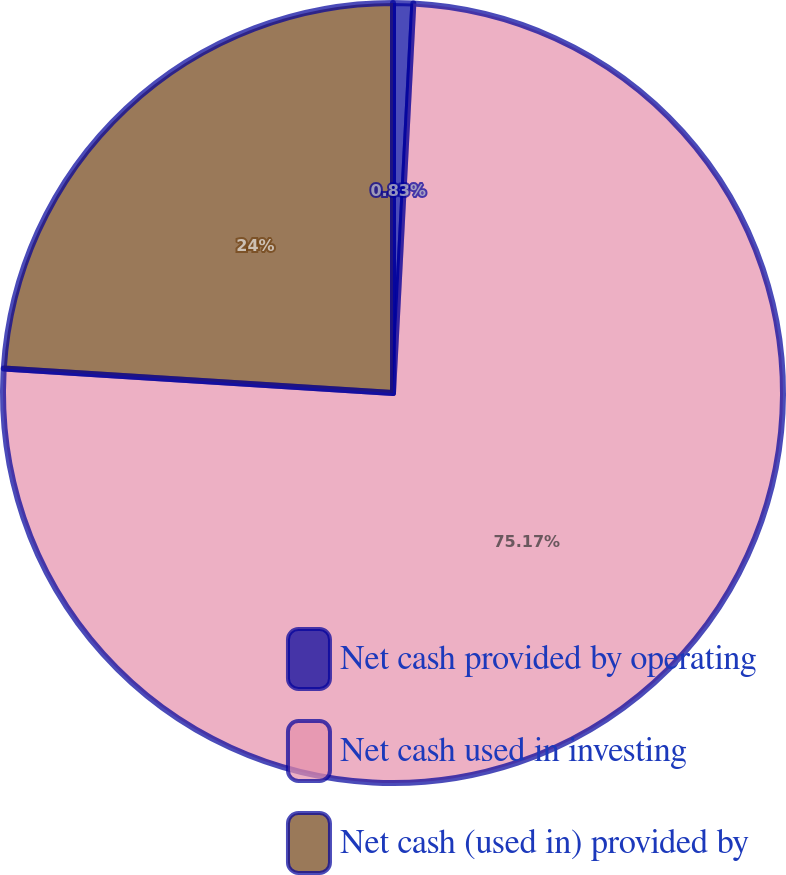<chart> <loc_0><loc_0><loc_500><loc_500><pie_chart><fcel>Net cash provided by operating<fcel>Net cash used in investing<fcel>Net cash (used in) provided by<nl><fcel>0.83%<fcel>75.17%<fcel>24.0%<nl></chart> 